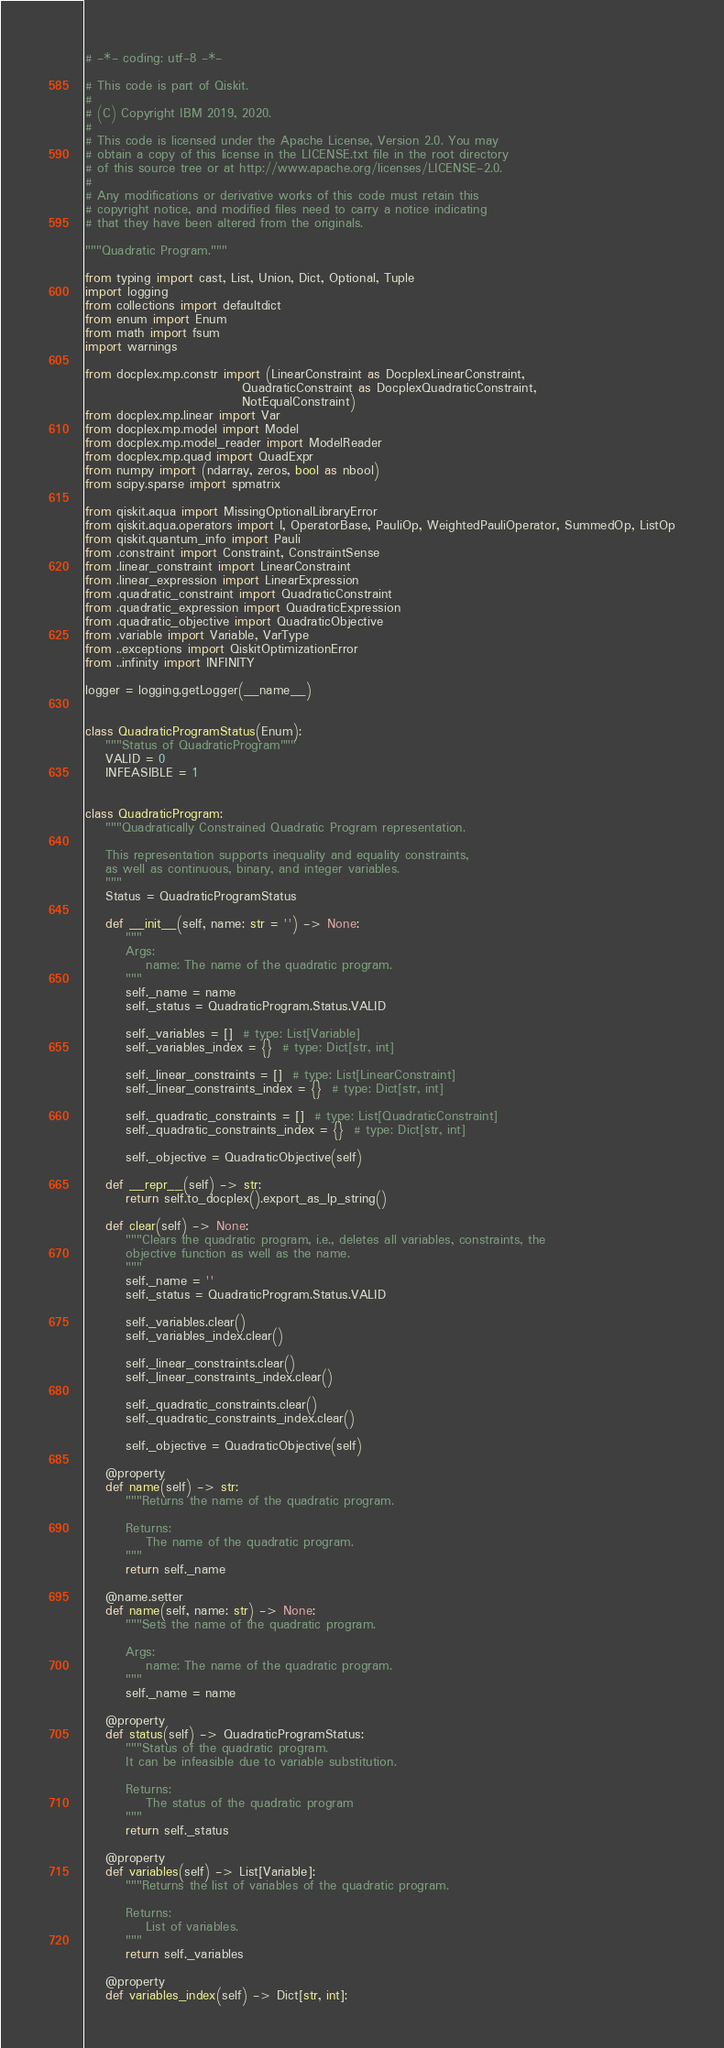Convert code to text. <code><loc_0><loc_0><loc_500><loc_500><_Python_># -*- coding: utf-8 -*-

# This code is part of Qiskit.
#
# (C) Copyright IBM 2019, 2020.
#
# This code is licensed under the Apache License, Version 2.0. You may
# obtain a copy of this license in the LICENSE.txt file in the root directory
# of this source tree or at http://www.apache.org/licenses/LICENSE-2.0.
#
# Any modifications or derivative works of this code must retain this
# copyright notice, and modified files need to carry a notice indicating
# that they have been altered from the originals.

"""Quadratic Program."""

from typing import cast, List, Union, Dict, Optional, Tuple
import logging
from collections import defaultdict
from enum import Enum
from math import fsum
import warnings

from docplex.mp.constr import (LinearConstraint as DocplexLinearConstraint,
                               QuadraticConstraint as DocplexQuadraticConstraint,
                               NotEqualConstraint)
from docplex.mp.linear import Var
from docplex.mp.model import Model
from docplex.mp.model_reader import ModelReader
from docplex.mp.quad import QuadExpr
from numpy import (ndarray, zeros, bool as nbool)
from scipy.sparse import spmatrix

from qiskit.aqua import MissingOptionalLibraryError
from qiskit.aqua.operators import I, OperatorBase, PauliOp, WeightedPauliOperator, SummedOp, ListOp
from qiskit.quantum_info import Pauli
from .constraint import Constraint, ConstraintSense
from .linear_constraint import LinearConstraint
from .linear_expression import LinearExpression
from .quadratic_constraint import QuadraticConstraint
from .quadratic_expression import QuadraticExpression
from .quadratic_objective import QuadraticObjective
from .variable import Variable, VarType
from ..exceptions import QiskitOptimizationError
from ..infinity import INFINITY

logger = logging.getLogger(__name__)


class QuadraticProgramStatus(Enum):
    """Status of QuadraticProgram"""
    VALID = 0
    INFEASIBLE = 1


class QuadraticProgram:
    """Quadratically Constrained Quadratic Program representation.

    This representation supports inequality and equality constraints,
    as well as continuous, binary, and integer variables.
    """
    Status = QuadraticProgramStatus

    def __init__(self, name: str = '') -> None:
        """
        Args:
            name: The name of the quadratic program.
        """
        self._name = name
        self._status = QuadraticProgram.Status.VALID

        self._variables = []  # type: List[Variable]
        self._variables_index = {}  # type: Dict[str, int]

        self._linear_constraints = []  # type: List[LinearConstraint]
        self._linear_constraints_index = {}  # type: Dict[str, int]

        self._quadratic_constraints = []  # type: List[QuadraticConstraint]
        self._quadratic_constraints_index = {}  # type: Dict[str, int]

        self._objective = QuadraticObjective(self)

    def __repr__(self) -> str:
        return self.to_docplex().export_as_lp_string()

    def clear(self) -> None:
        """Clears the quadratic program, i.e., deletes all variables, constraints, the
        objective function as well as the name.
        """
        self._name = ''
        self._status = QuadraticProgram.Status.VALID

        self._variables.clear()
        self._variables_index.clear()

        self._linear_constraints.clear()
        self._linear_constraints_index.clear()

        self._quadratic_constraints.clear()
        self._quadratic_constraints_index.clear()

        self._objective = QuadraticObjective(self)

    @property
    def name(self) -> str:
        """Returns the name of the quadratic program.

        Returns:
            The name of the quadratic program.
        """
        return self._name

    @name.setter
    def name(self, name: str) -> None:
        """Sets the name of the quadratic program.

        Args:
            name: The name of the quadratic program.
        """
        self._name = name

    @property
    def status(self) -> QuadraticProgramStatus:
        """Status of the quadratic program.
        It can be infeasible due to variable substitution.

        Returns:
            The status of the quadratic program
        """
        return self._status

    @property
    def variables(self) -> List[Variable]:
        """Returns the list of variables of the quadratic program.

        Returns:
            List of variables.
        """
        return self._variables

    @property
    def variables_index(self) -> Dict[str, int]:</code> 